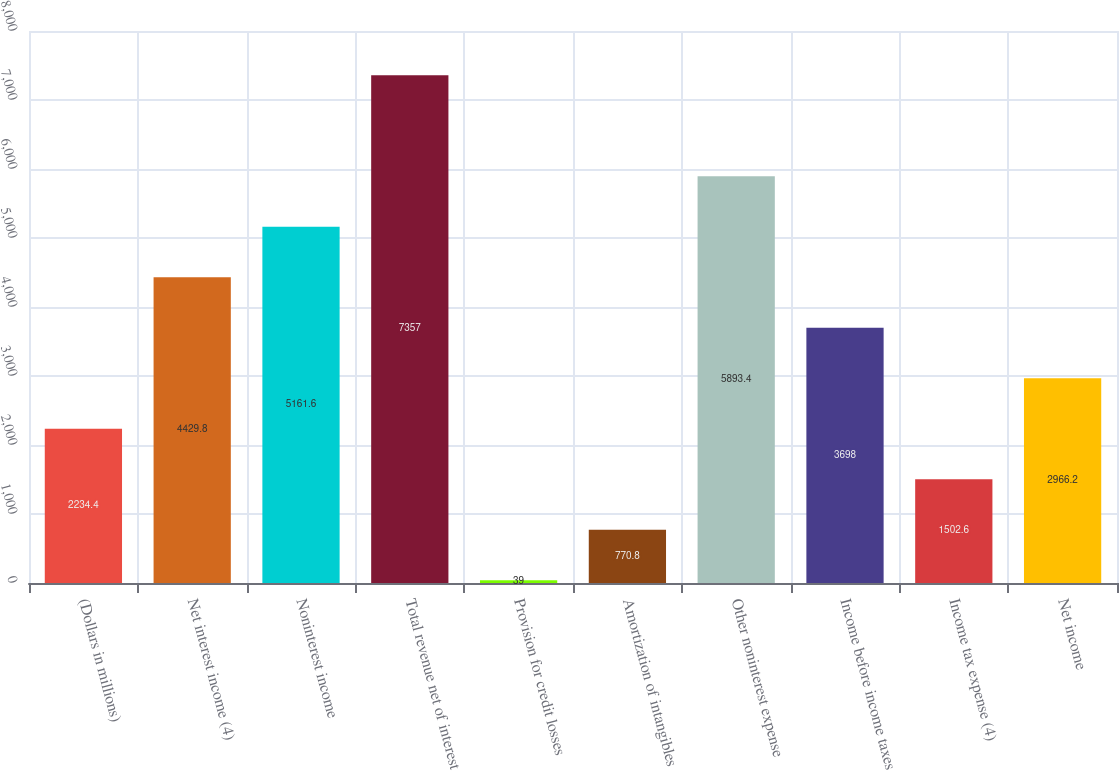Convert chart. <chart><loc_0><loc_0><loc_500><loc_500><bar_chart><fcel>(Dollars in millions)<fcel>Net interest income (4)<fcel>Noninterest income<fcel>Total revenue net of interest<fcel>Provision for credit losses<fcel>Amortization of intangibles<fcel>Other noninterest expense<fcel>Income before income taxes<fcel>Income tax expense (4)<fcel>Net income<nl><fcel>2234.4<fcel>4429.8<fcel>5161.6<fcel>7357<fcel>39<fcel>770.8<fcel>5893.4<fcel>3698<fcel>1502.6<fcel>2966.2<nl></chart> 